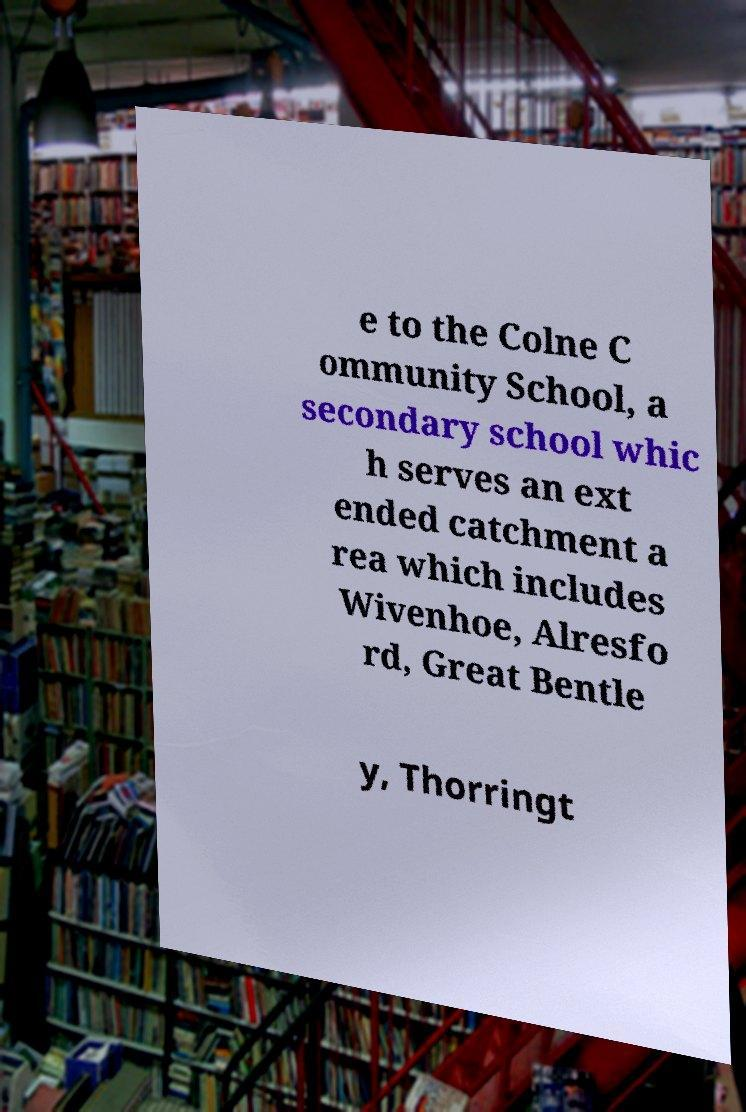What messages or text are displayed in this image? I need them in a readable, typed format. e to the Colne C ommunity School, a secondary school whic h serves an ext ended catchment a rea which includes Wivenhoe, Alresfo rd, Great Bentle y, Thorringt 